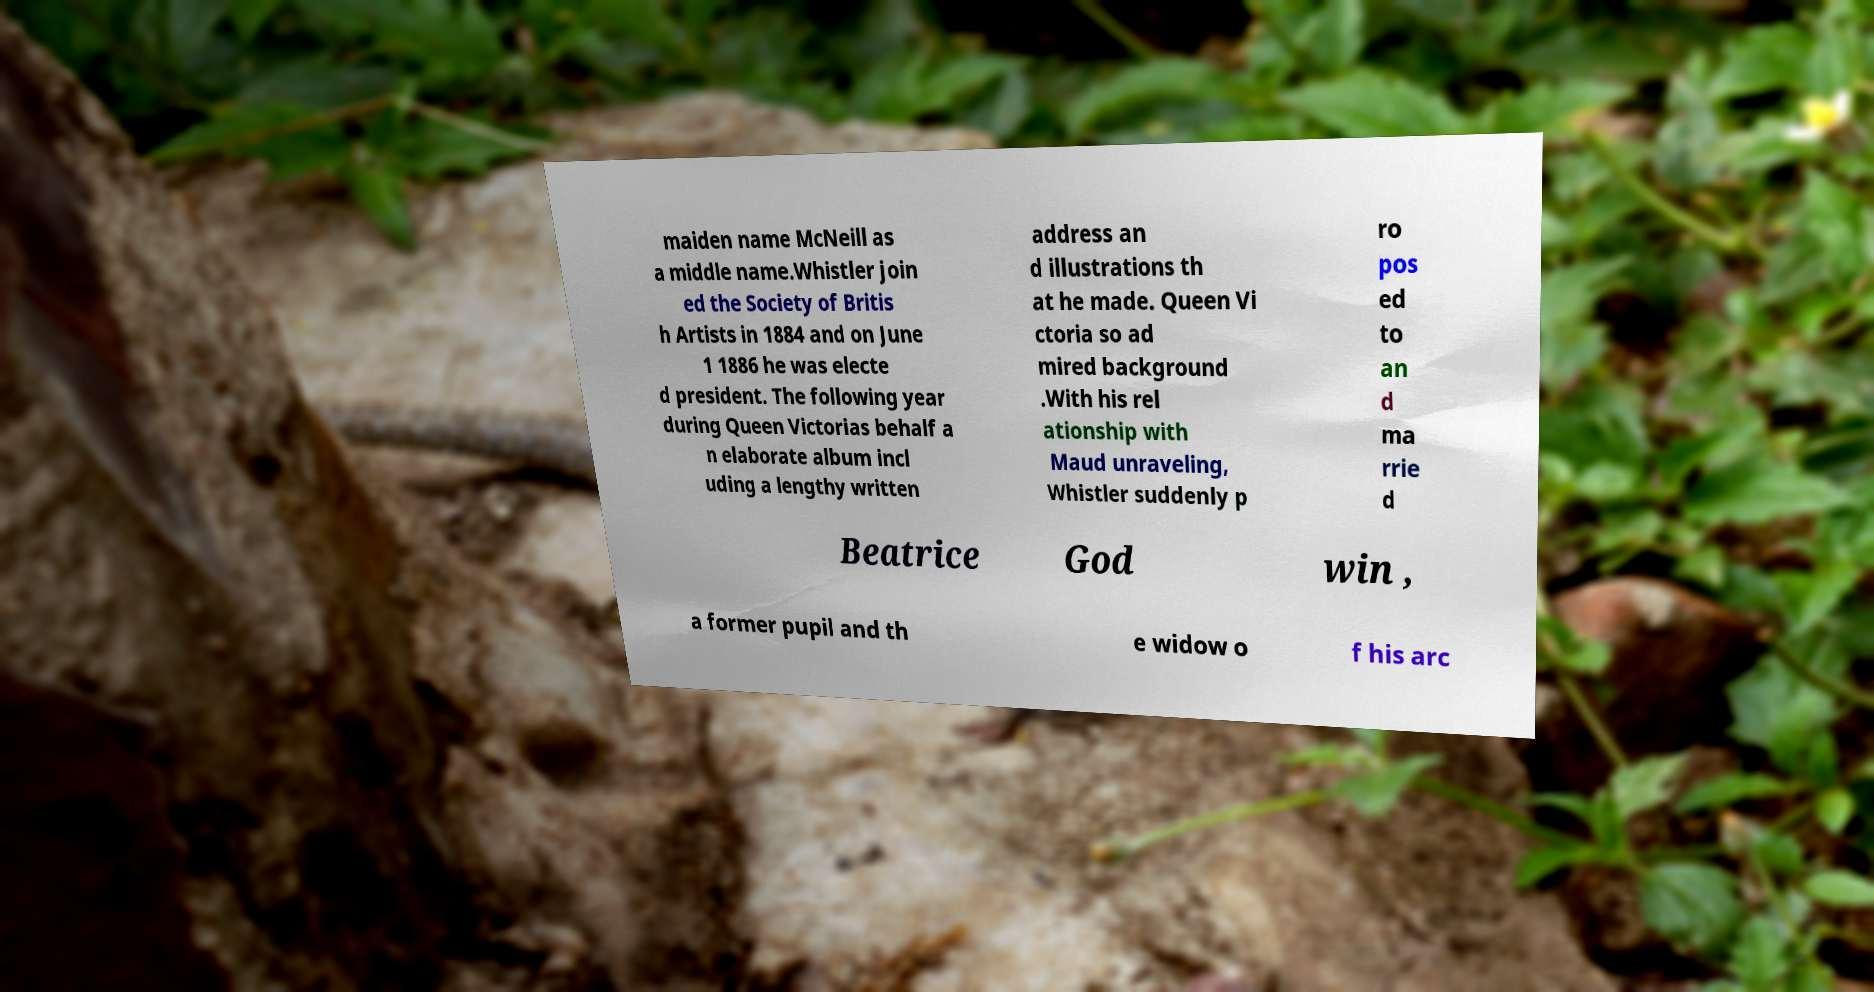Can you read and provide the text displayed in the image?This photo seems to have some interesting text. Can you extract and type it out for me? maiden name McNeill as a middle name.Whistler join ed the Society of Britis h Artists in 1884 and on June 1 1886 he was electe d president. The following year during Queen Victorias behalf a n elaborate album incl uding a lengthy written address an d illustrations th at he made. Queen Vi ctoria so ad mired background .With his rel ationship with Maud unraveling, Whistler suddenly p ro pos ed to an d ma rrie d Beatrice God win , a former pupil and th e widow o f his arc 